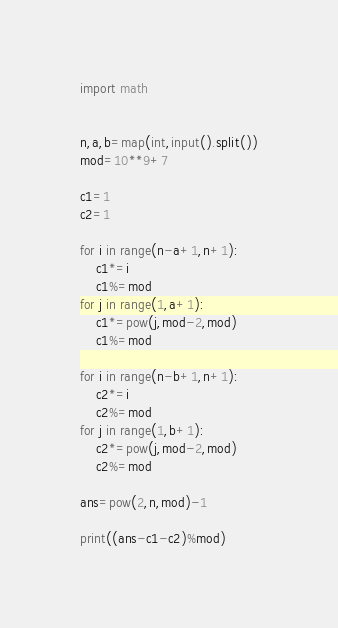Convert code to text. <code><loc_0><loc_0><loc_500><loc_500><_Python_>import math


n,a,b=map(int,input().split())
mod=10**9+7

c1=1
c2=1

for i in range(n-a+1,n+1):
    c1*=i
    c1%=mod
for j in range(1,a+1):
    c1*=pow(j,mod-2,mod)
    c1%=mod
    
for i in range(n-b+1,n+1):
    c2*=i
    c2%=mod
for j in range(1,b+1):
    c2*=pow(j,mod-2,mod)
    c2%=mod

ans=pow(2,n,mod)-1

print((ans-c1-c2)%mod)
</code> 